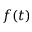Convert formula to latex. <formula><loc_0><loc_0><loc_500><loc_500>f ( t )</formula> 